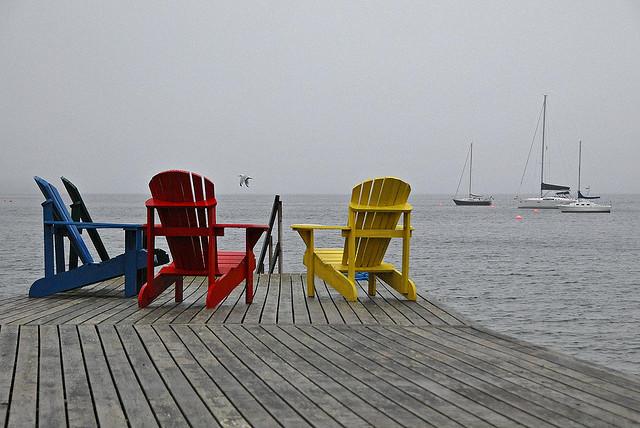Is there an ocean?
Answer briefly. Yes. What kind of area is this?
Write a very short answer. Pier. What are the chairs sitting on?
Give a very brief answer. Dock. Are these chairs all the same color?
Short answer required. No. 